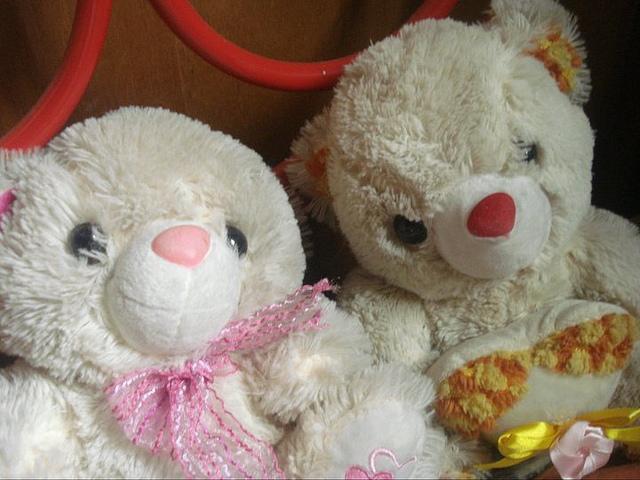What color are the teddy bears?
Quick response, please. White. What color is the teddy bear?
Write a very short answer. White. How many teddy bears are there?
Give a very brief answer. 2. What implies that the beat on the right is a girl?
Concise answer only. Pink. What color is the doll on the right's bowtie?
Quick response, please. Pink. Do the teddy bears appear to be a boy and a girl?
Keep it brief. Yes. Are the bear's eyes in the right place?
Keep it brief. Yes. What is the bear made of?
Give a very brief answer. Fur. What color is the white bear's nose?
Keep it brief. Pink. How many of the teddy bears eyes are shown in the photo?
Write a very short answer. 4. What is around the neck of the bear on the right?
Answer briefly. Nothing. 